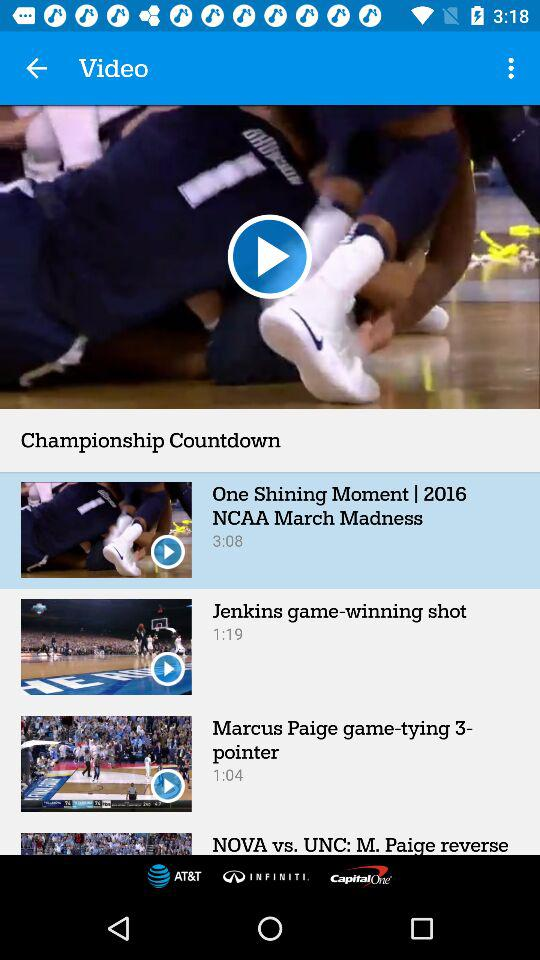What is the duration of Jenkins' game-winning shot? The duration of Jenkins' game-winning shot is 1:19. 